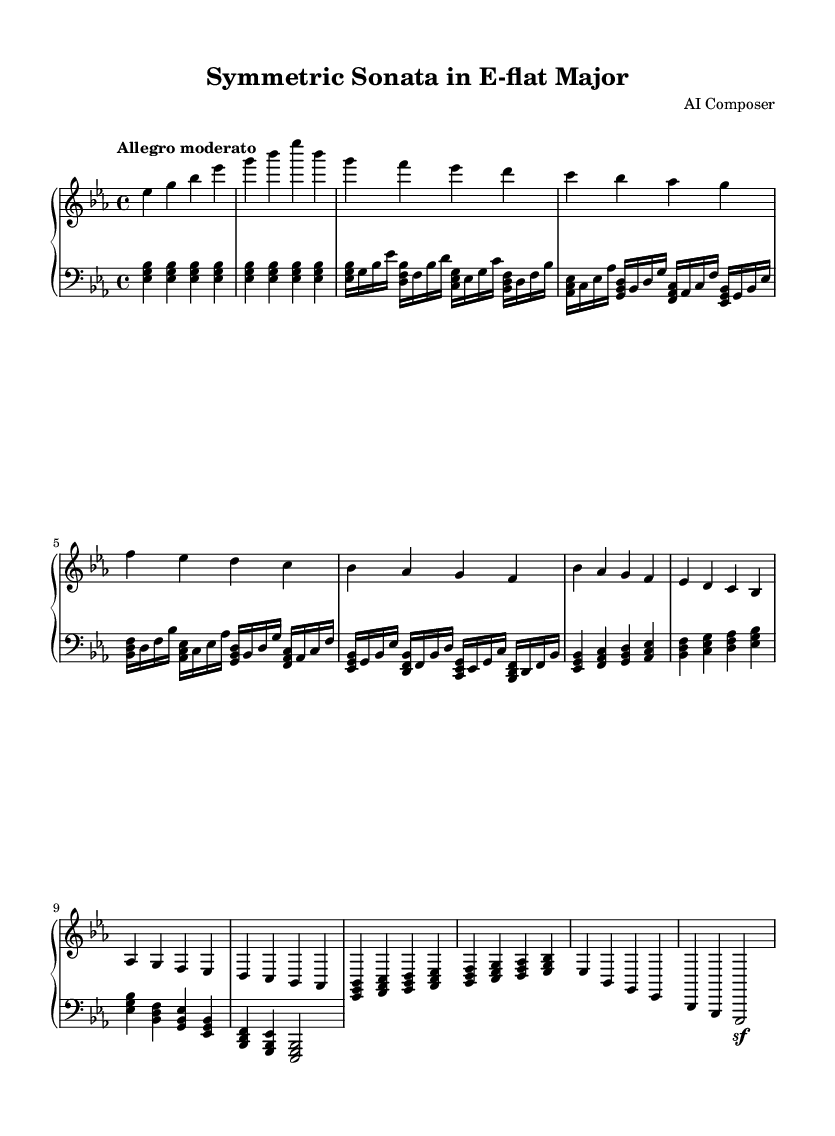What is the key signature of this music? The key signature is indicated by the sharp or flat symbols at the beginning of the staff. This piece has three flats, which corresponds to E-flat major.
Answer: E-flat major What is the time signature of this piece? The time signature is given at the start of the music. It is written as a fraction, with the top number representing beats per measure and the bottom number indicating the note that gets one beat. Here, it is 4/4, meaning there are four quarter-note beats per measure.
Answer: 4/4 What is the tempo marking for this piece? The tempo is indicated above the staff as "Allegro moderato," which describes the speed of the piece. This is a common Italian term used in music to denote a moderate, lively pace.
Answer: Allegro moderato How many distinct themes are present in this piece? By examining the structure of the music, we can see two themes labeled as 'Theme A' and 'Theme B.' Each theme represents a different melodic idea that is explored throughout the piece.
Answer: 2 Which section follows the introduction in the music? Looking at the layout of the music, the section that comes after the introduction is Theme A. This can be identified by the labeling in the music.
Answer: Theme A What techniques are displayed in the development section? The development section is characterized by the use of chords and arpeggiated figures shown in the simplified notation. This often involves showcasing variations of the main themes, highlighting musical exploration and creativity.
Answer: Chords and arpeggiated figures What is the final section of this piece called? The final section of the piece is typically referred to as the Coda, which is marked specifically as such in the music. The Coda concludes the musical ideas presented earlier.
Answer: Coda 